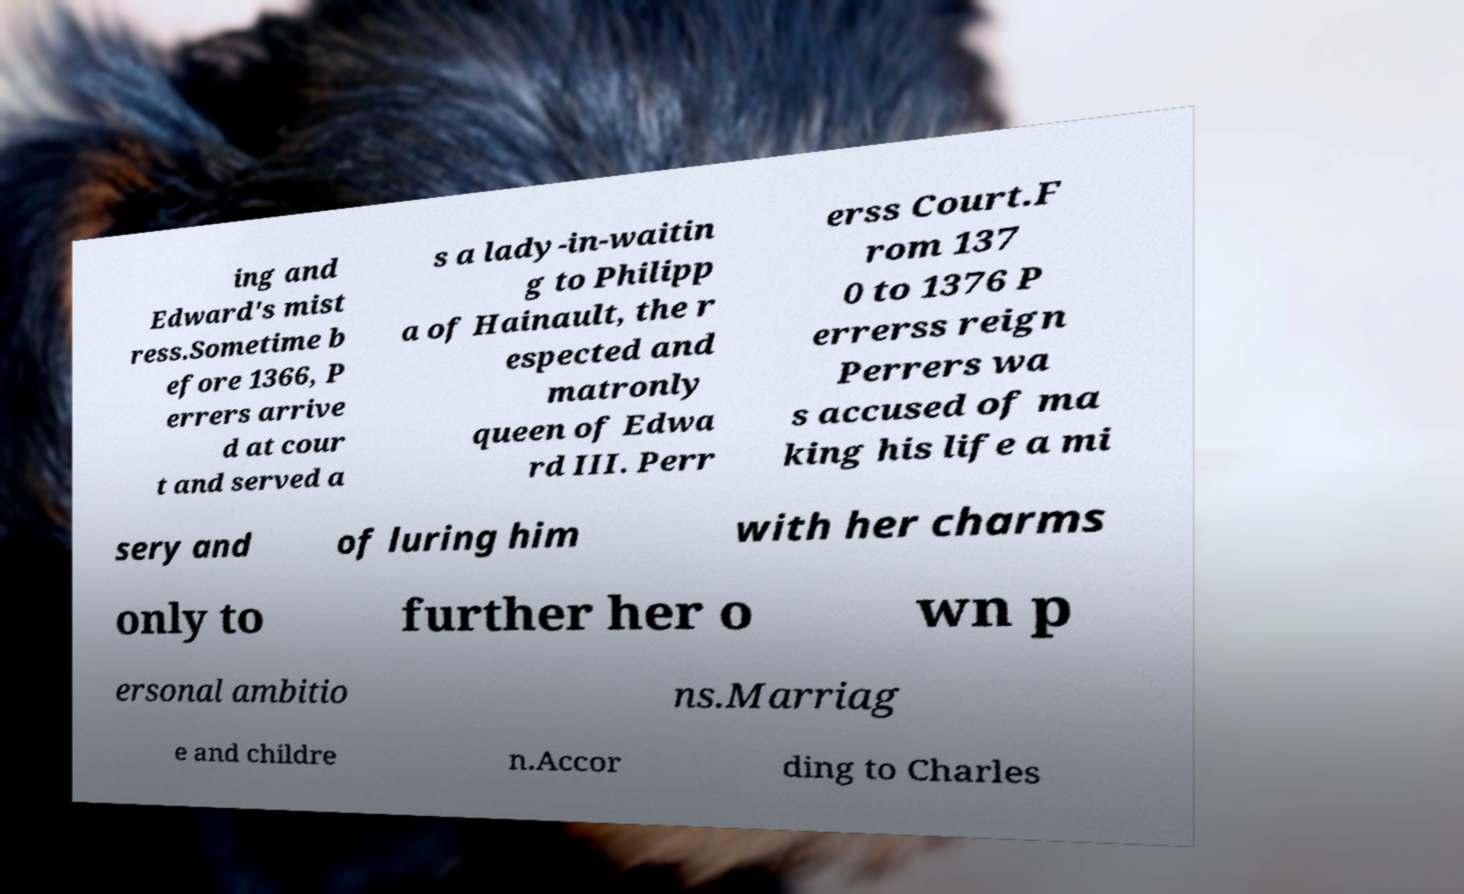Can you read and provide the text displayed in the image?This photo seems to have some interesting text. Can you extract and type it out for me? ing and Edward's mist ress.Sometime b efore 1366, P errers arrive d at cour t and served a s a lady-in-waitin g to Philipp a of Hainault, the r espected and matronly queen of Edwa rd III. Perr erss Court.F rom 137 0 to 1376 P errerss reign Perrers wa s accused of ma king his life a mi sery and of luring him with her charms only to further her o wn p ersonal ambitio ns.Marriag e and childre n.Accor ding to Charles 